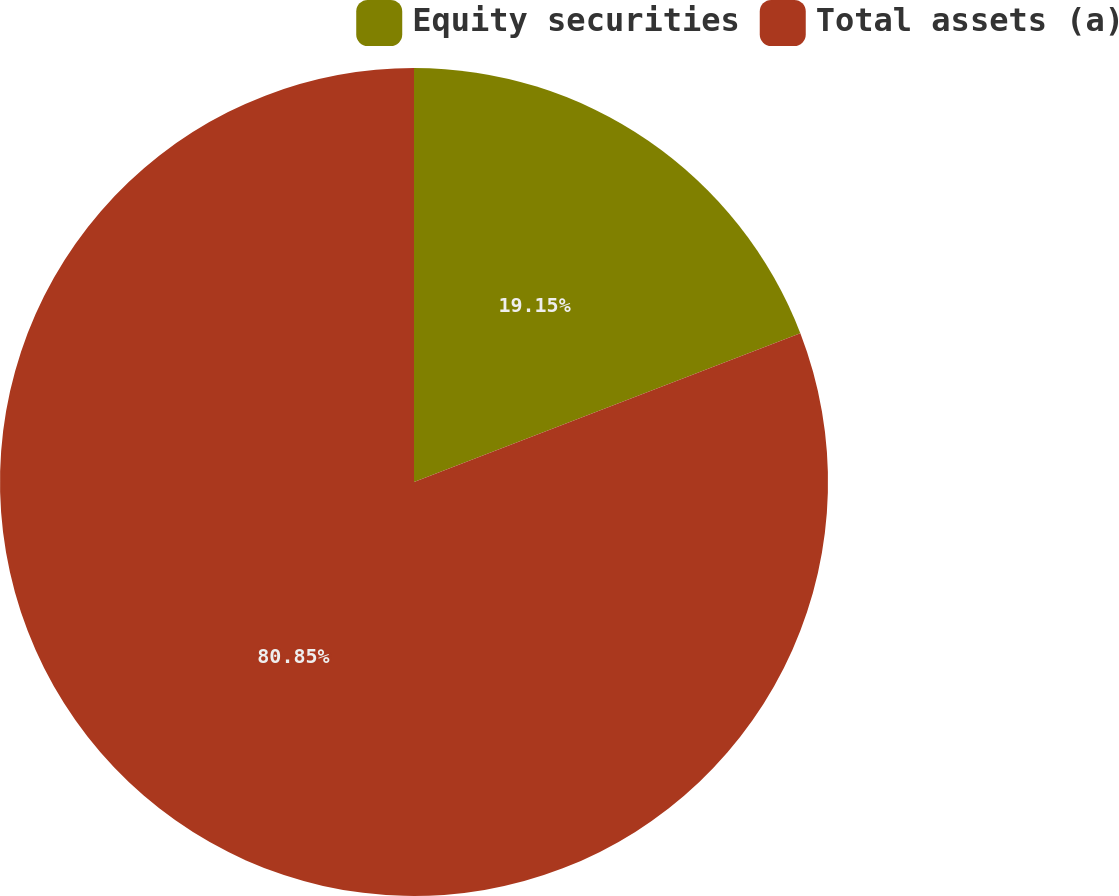<chart> <loc_0><loc_0><loc_500><loc_500><pie_chart><fcel>Equity securities<fcel>Total assets (a)<nl><fcel>19.15%<fcel>80.85%<nl></chart> 